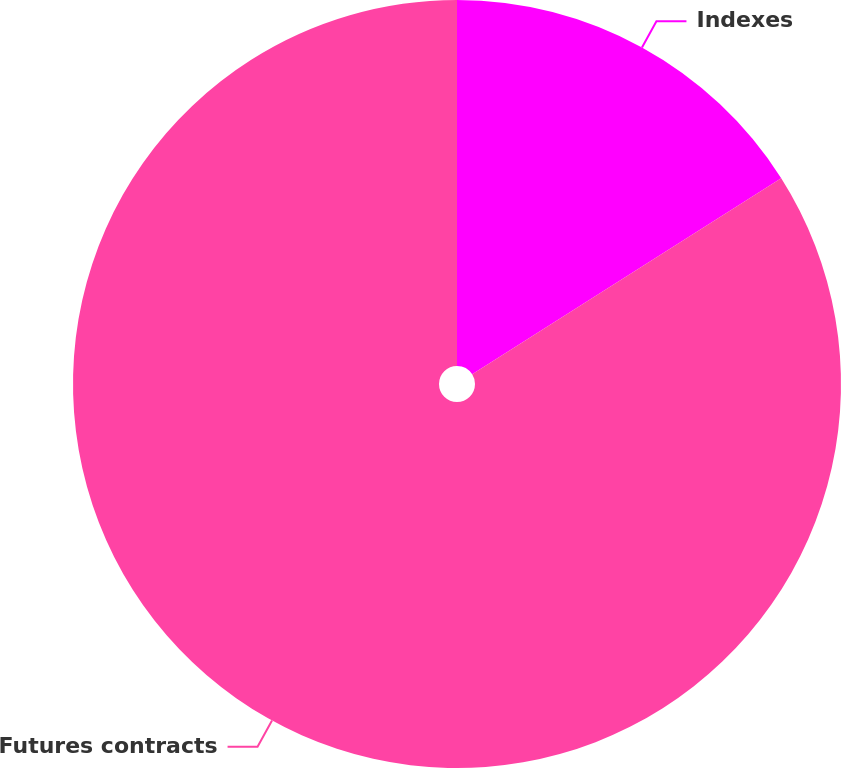Convert chart. <chart><loc_0><loc_0><loc_500><loc_500><pie_chart><fcel>Indexes<fcel>Futures contracts<nl><fcel>16.0%<fcel>84.0%<nl></chart> 